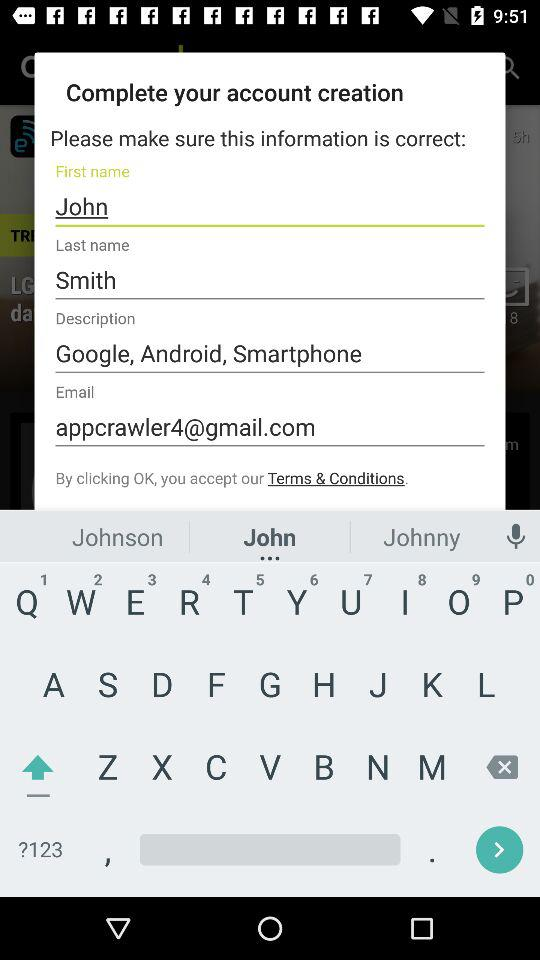How many text fields are there on the screen?
Answer the question using a single word or phrase. 4 